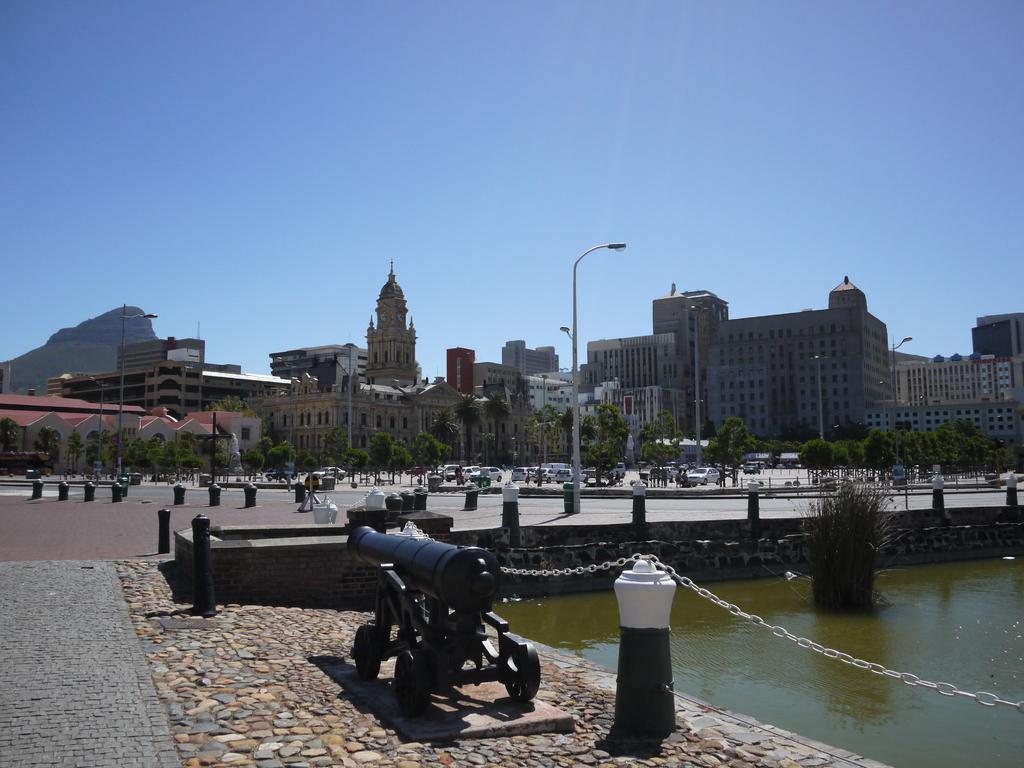Could you give a brief overview of what you see in this image? In the middle of the image we can see a cannon, beside to it we can find a chain and water, in the background we can see few poles, buildings, trees, vehicles and group of people, and also we can see a hill. 